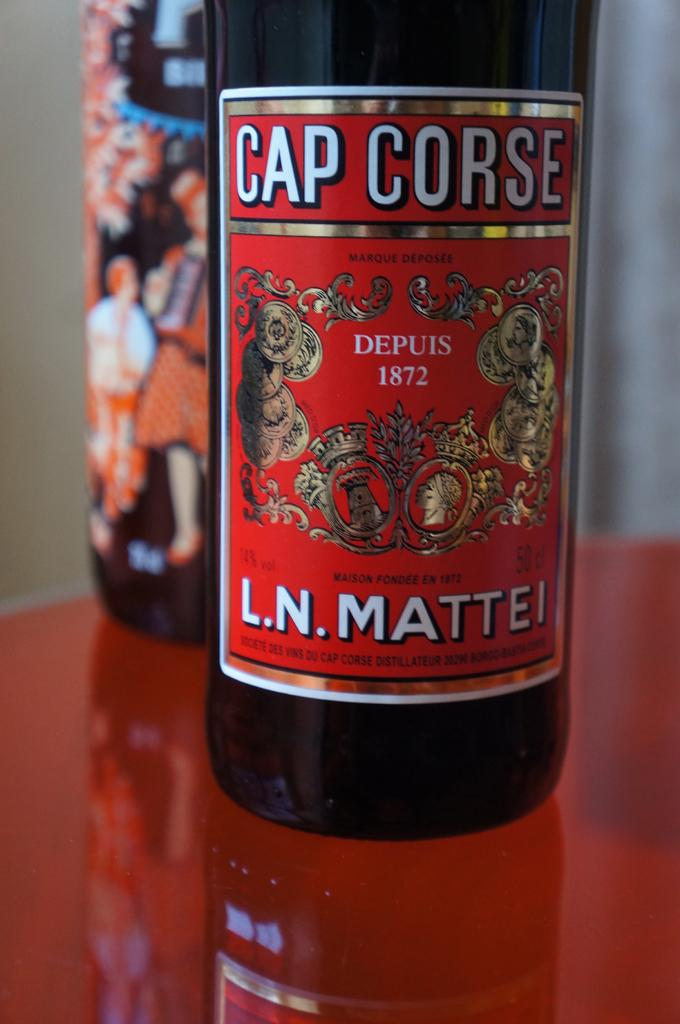<image>
Summarize the visual content of the image. A bottle of Cap Corse sits on a red glass table next to a different bottle. 